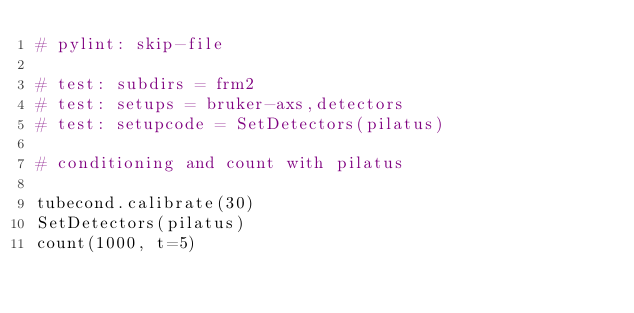Convert code to text. <code><loc_0><loc_0><loc_500><loc_500><_Python_># pylint: skip-file

# test: subdirs = frm2
# test: setups = bruker-axs,detectors
# test: setupcode = SetDetectors(pilatus)

# conditioning and count with pilatus

tubecond.calibrate(30)
SetDetectors(pilatus)
count(1000, t=5)
</code> 